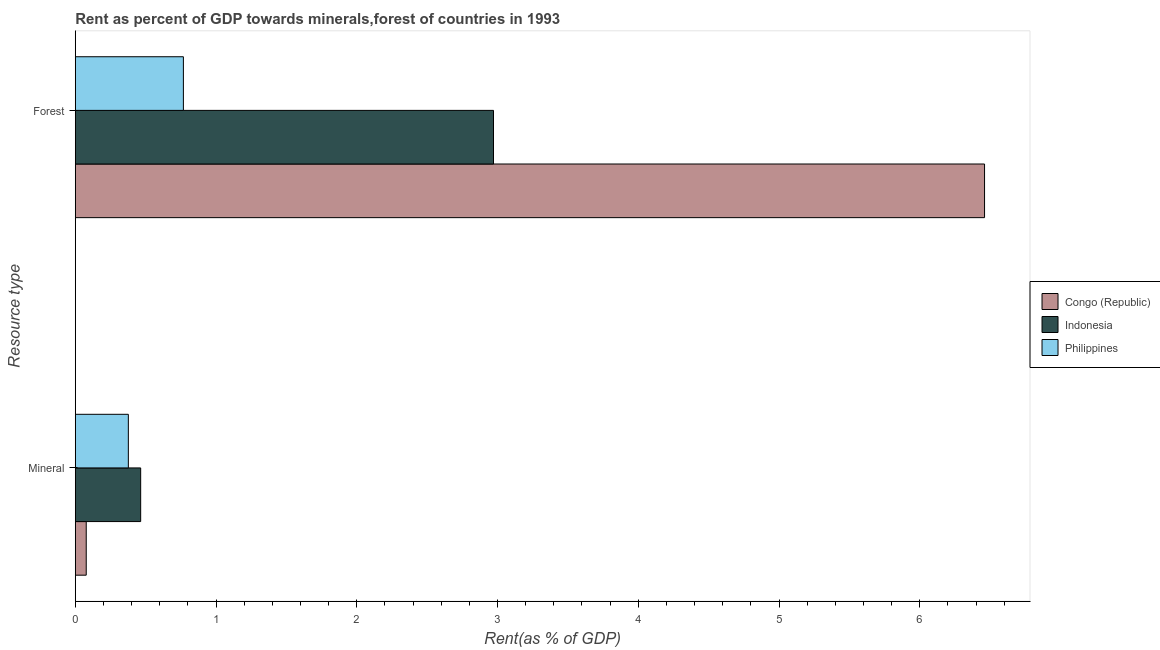How many different coloured bars are there?
Your answer should be very brief. 3. How many groups of bars are there?
Give a very brief answer. 2. Are the number of bars on each tick of the Y-axis equal?
Provide a succinct answer. Yes. What is the label of the 2nd group of bars from the top?
Offer a terse response. Mineral. What is the forest rent in Congo (Republic)?
Keep it short and to the point. 6.46. Across all countries, what is the maximum forest rent?
Provide a succinct answer. 6.46. Across all countries, what is the minimum mineral rent?
Make the answer very short. 0.08. In which country was the mineral rent maximum?
Ensure brevity in your answer.  Indonesia. In which country was the mineral rent minimum?
Ensure brevity in your answer.  Congo (Republic). What is the total mineral rent in the graph?
Your response must be concise. 0.92. What is the difference between the mineral rent in Indonesia and that in Philippines?
Keep it short and to the point. 0.09. What is the difference between the mineral rent in Congo (Republic) and the forest rent in Indonesia?
Ensure brevity in your answer.  -2.89. What is the average forest rent per country?
Provide a short and direct response. 3.4. What is the difference between the mineral rent and forest rent in Congo (Republic)?
Offer a very short reply. -6.38. What is the ratio of the forest rent in Philippines to that in Indonesia?
Offer a terse response. 0.26. Is the forest rent in Indonesia less than that in Philippines?
Offer a very short reply. No. What does the 3rd bar from the top in Forest represents?
Offer a terse response. Congo (Republic). What does the 1st bar from the bottom in Mineral represents?
Provide a succinct answer. Congo (Republic). How many countries are there in the graph?
Provide a succinct answer. 3. What is the difference between two consecutive major ticks on the X-axis?
Offer a very short reply. 1. Where does the legend appear in the graph?
Give a very brief answer. Center right. How many legend labels are there?
Give a very brief answer. 3. What is the title of the graph?
Your answer should be very brief. Rent as percent of GDP towards minerals,forest of countries in 1993. What is the label or title of the X-axis?
Offer a terse response. Rent(as % of GDP). What is the label or title of the Y-axis?
Provide a short and direct response. Resource type. What is the Rent(as % of GDP) of Congo (Republic) in Mineral?
Your response must be concise. 0.08. What is the Rent(as % of GDP) of Indonesia in Mineral?
Your answer should be very brief. 0.46. What is the Rent(as % of GDP) in Philippines in Mineral?
Ensure brevity in your answer.  0.38. What is the Rent(as % of GDP) of Congo (Republic) in Forest?
Offer a terse response. 6.46. What is the Rent(as % of GDP) in Indonesia in Forest?
Ensure brevity in your answer.  2.97. What is the Rent(as % of GDP) of Philippines in Forest?
Provide a short and direct response. 0.77. Across all Resource type, what is the maximum Rent(as % of GDP) in Congo (Republic)?
Offer a very short reply. 6.46. Across all Resource type, what is the maximum Rent(as % of GDP) in Indonesia?
Provide a succinct answer. 2.97. Across all Resource type, what is the maximum Rent(as % of GDP) in Philippines?
Make the answer very short. 0.77. Across all Resource type, what is the minimum Rent(as % of GDP) in Congo (Republic)?
Offer a very short reply. 0.08. Across all Resource type, what is the minimum Rent(as % of GDP) in Indonesia?
Ensure brevity in your answer.  0.46. Across all Resource type, what is the minimum Rent(as % of GDP) in Philippines?
Provide a short and direct response. 0.38. What is the total Rent(as % of GDP) in Congo (Republic) in the graph?
Offer a very short reply. 6.54. What is the total Rent(as % of GDP) in Indonesia in the graph?
Make the answer very short. 3.44. What is the total Rent(as % of GDP) of Philippines in the graph?
Your answer should be very brief. 1.14. What is the difference between the Rent(as % of GDP) in Congo (Republic) in Mineral and that in Forest?
Offer a terse response. -6.38. What is the difference between the Rent(as % of GDP) in Indonesia in Mineral and that in Forest?
Ensure brevity in your answer.  -2.51. What is the difference between the Rent(as % of GDP) of Philippines in Mineral and that in Forest?
Offer a terse response. -0.39. What is the difference between the Rent(as % of GDP) in Congo (Republic) in Mineral and the Rent(as % of GDP) in Indonesia in Forest?
Keep it short and to the point. -2.89. What is the difference between the Rent(as % of GDP) of Congo (Republic) in Mineral and the Rent(as % of GDP) of Philippines in Forest?
Make the answer very short. -0.69. What is the difference between the Rent(as % of GDP) in Indonesia in Mineral and the Rent(as % of GDP) in Philippines in Forest?
Your answer should be compact. -0.3. What is the average Rent(as % of GDP) of Congo (Republic) per Resource type?
Your response must be concise. 3.27. What is the average Rent(as % of GDP) in Indonesia per Resource type?
Keep it short and to the point. 1.72. What is the average Rent(as % of GDP) of Philippines per Resource type?
Keep it short and to the point. 0.57. What is the difference between the Rent(as % of GDP) of Congo (Republic) and Rent(as % of GDP) of Indonesia in Mineral?
Ensure brevity in your answer.  -0.39. What is the difference between the Rent(as % of GDP) of Congo (Republic) and Rent(as % of GDP) of Philippines in Mineral?
Your answer should be very brief. -0.3. What is the difference between the Rent(as % of GDP) of Indonesia and Rent(as % of GDP) of Philippines in Mineral?
Ensure brevity in your answer.  0.09. What is the difference between the Rent(as % of GDP) in Congo (Republic) and Rent(as % of GDP) in Indonesia in Forest?
Provide a succinct answer. 3.49. What is the difference between the Rent(as % of GDP) in Congo (Republic) and Rent(as % of GDP) in Philippines in Forest?
Your answer should be compact. 5.69. What is the difference between the Rent(as % of GDP) in Indonesia and Rent(as % of GDP) in Philippines in Forest?
Make the answer very short. 2.2. What is the ratio of the Rent(as % of GDP) in Congo (Republic) in Mineral to that in Forest?
Provide a succinct answer. 0.01. What is the ratio of the Rent(as % of GDP) in Indonesia in Mineral to that in Forest?
Your response must be concise. 0.16. What is the ratio of the Rent(as % of GDP) of Philippines in Mineral to that in Forest?
Your answer should be compact. 0.49. What is the difference between the highest and the second highest Rent(as % of GDP) of Congo (Republic)?
Provide a short and direct response. 6.38. What is the difference between the highest and the second highest Rent(as % of GDP) of Indonesia?
Your answer should be very brief. 2.51. What is the difference between the highest and the second highest Rent(as % of GDP) in Philippines?
Make the answer very short. 0.39. What is the difference between the highest and the lowest Rent(as % of GDP) of Congo (Republic)?
Keep it short and to the point. 6.38. What is the difference between the highest and the lowest Rent(as % of GDP) of Indonesia?
Your response must be concise. 2.51. What is the difference between the highest and the lowest Rent(as % of GDP) in Philippines?
Provide a short and direct response. 0.39. 